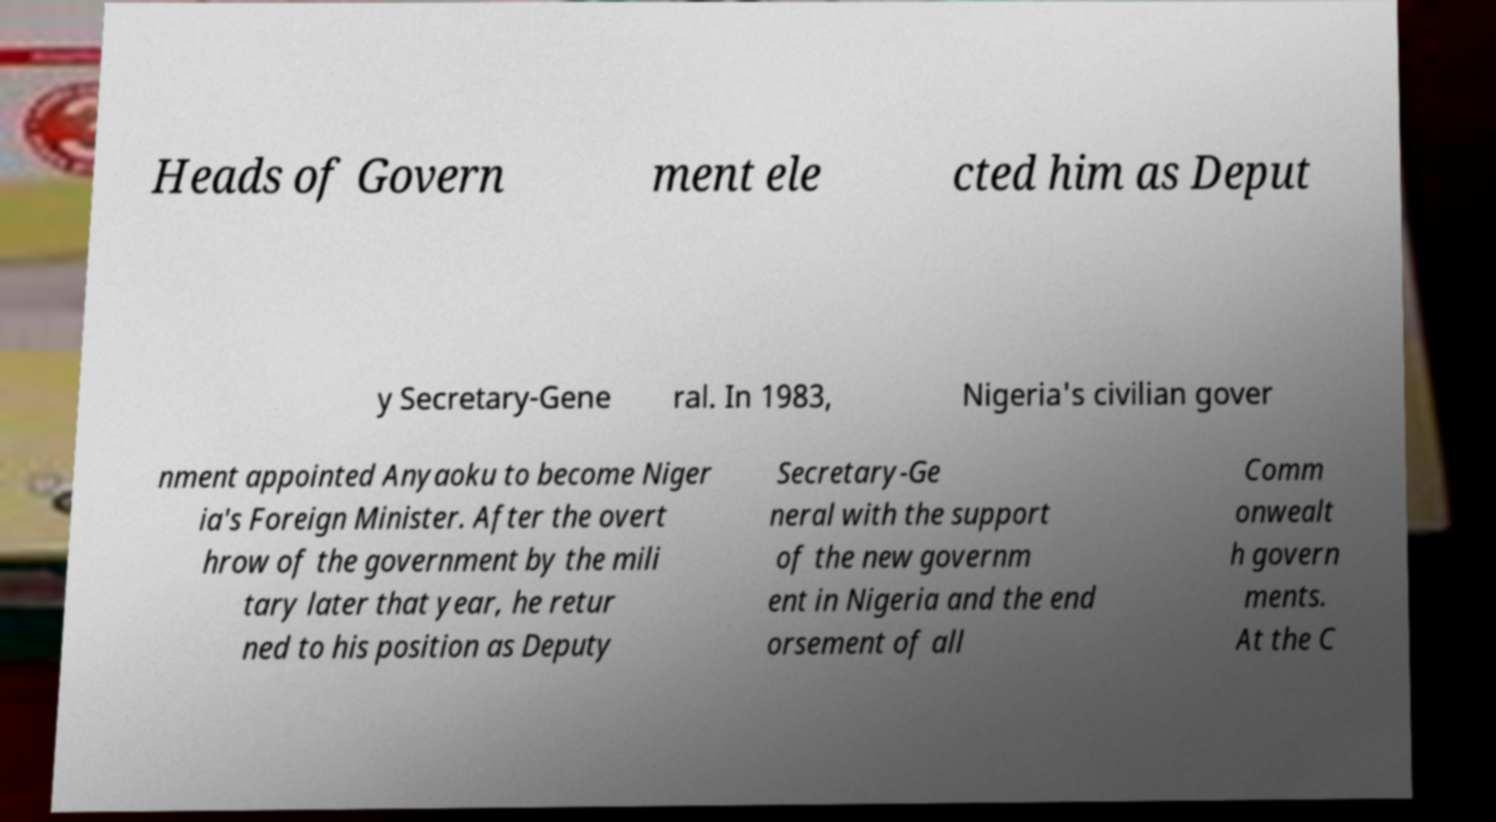Please read and relay the text visible in this image. What does it say? Heads of Govern ment ele cted him as Deput y Secretary-Gene ral. In 1983, Nigeria's civilian gover nment appointed Anyaoku to become Niger ia's Foreign Minister. After the overt hrow of the government by the mili tary later that year, he retur ned to his position as Deputy Secretary-Ge neral with the support of the new governm ent in Nigeria and the end orsement of all Comm onwealt h govern ments. At the C 